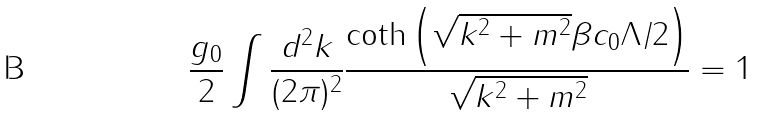<formula> <loc_0><loc_0><loc_500><loc_500>\frac { g _ { 0 } } { 2 } \int \frac { d ^ { 2 } k } { ( 2 \pi ) ^ { 2 } } \frac { \coth \left ( \sqrt { k ^ { 2 } + m ^ { 2 } } \beta c _ { 0 } \Lambda / 2 \right ) } { \sqrt { k ^ { 2 } + m ^ { 2 } } } = 1</formula> 